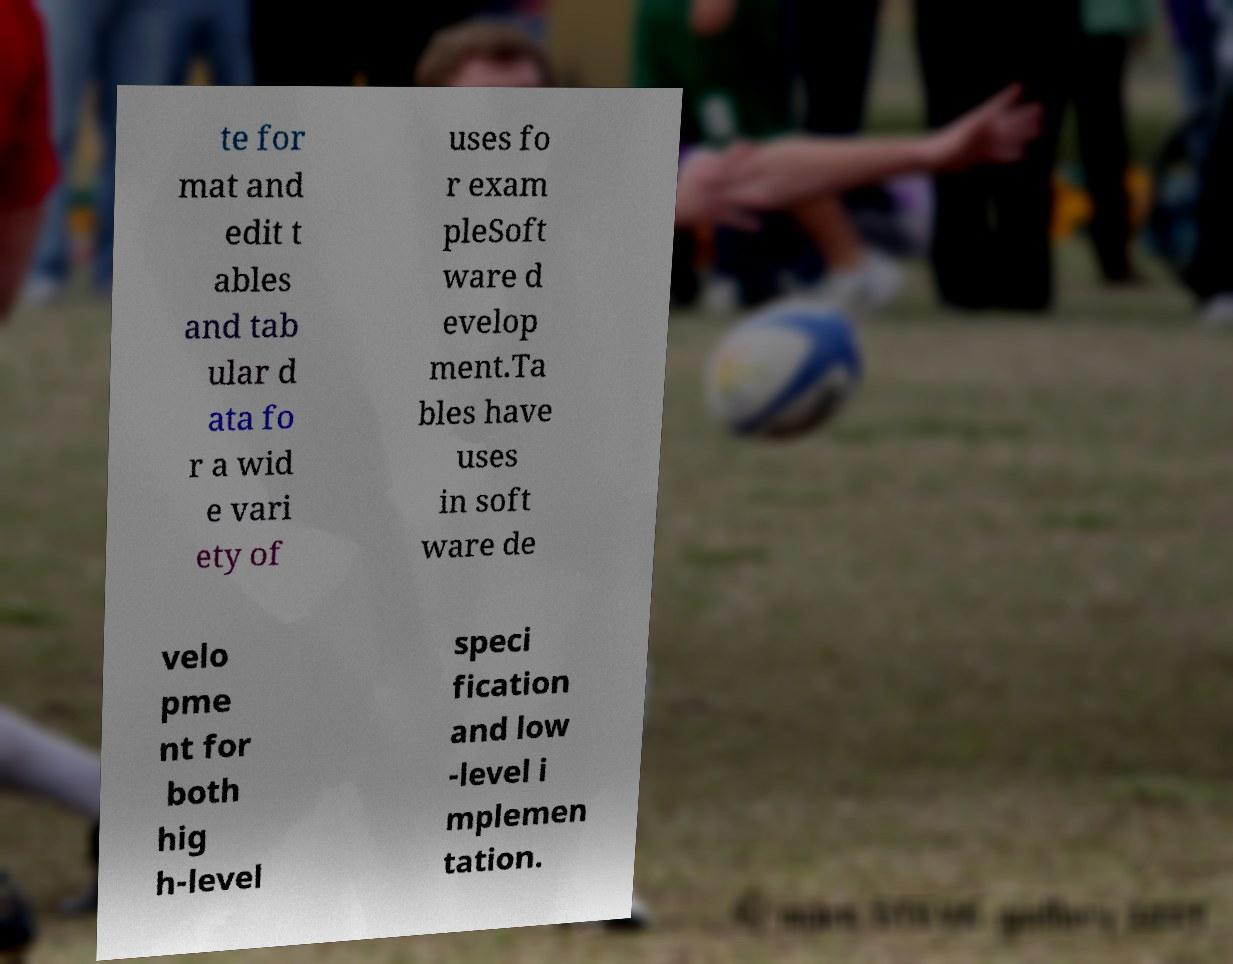Could you assist in decoding the text presented in this image and type it out clearly? te for mat and edit t ables and tab ular d ata fo r a wid e vari ety of uses fo r exam pleSoft ware d evelop ment.Ta bles have uses in soft ware de velo pme nt for both hig h-level speci fication and low -level i mplemen tation. 